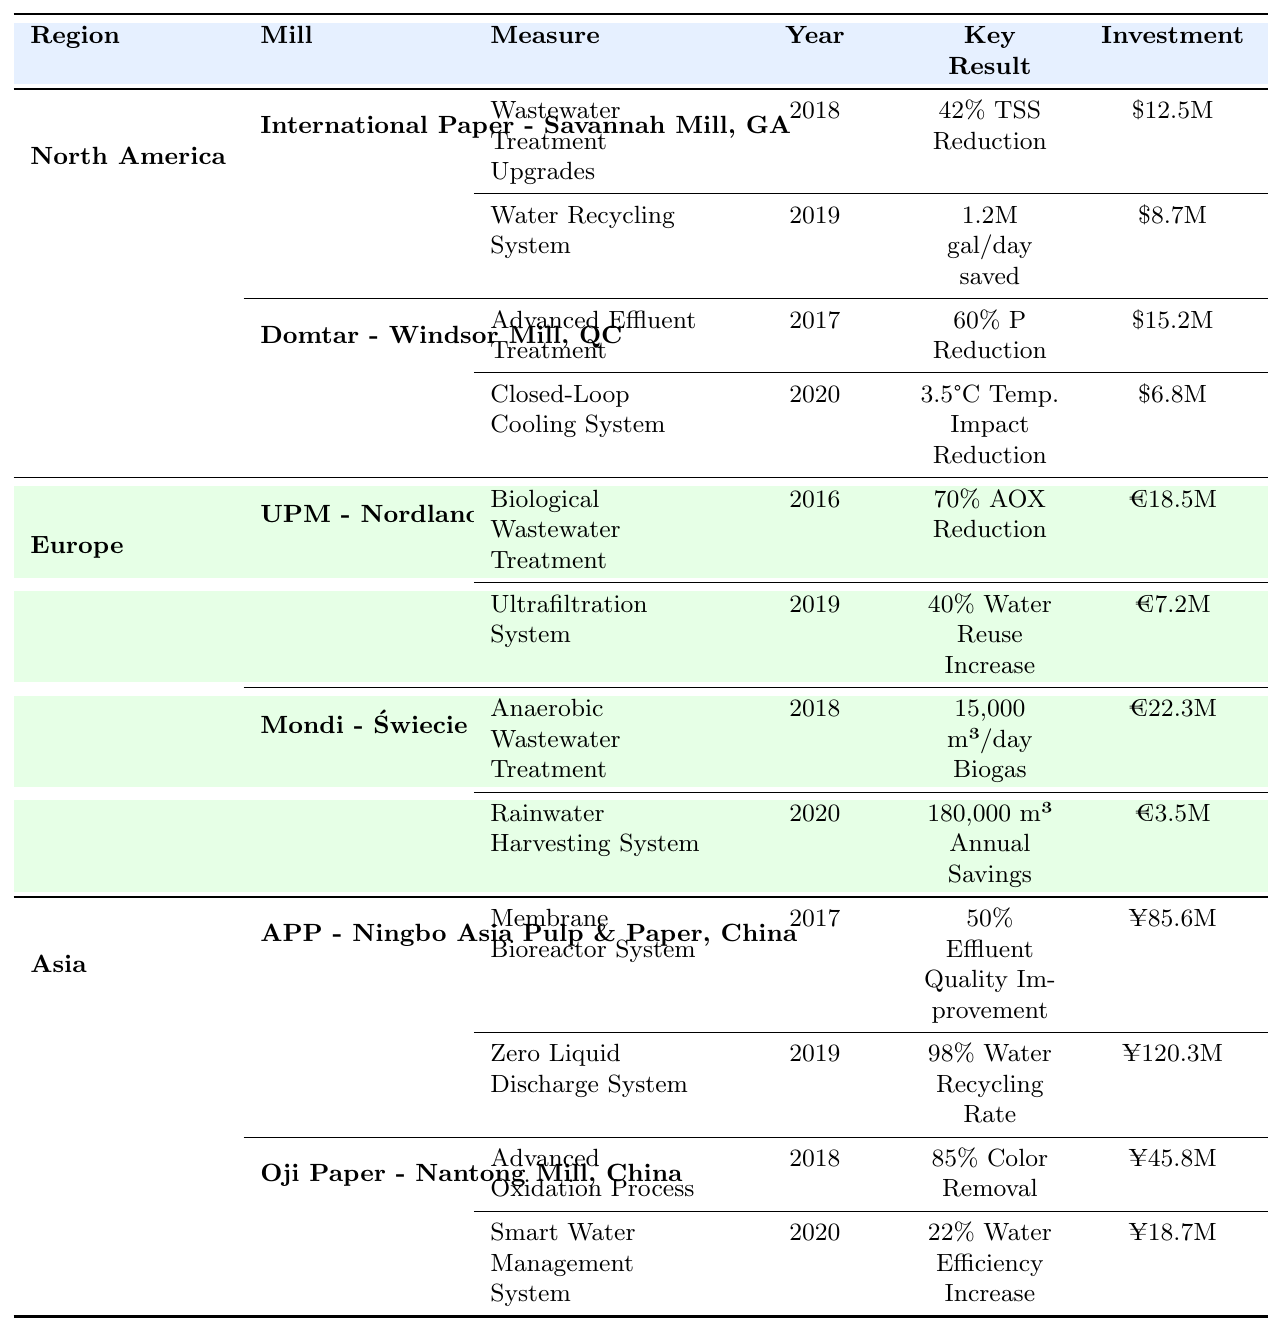What year was the Water Recycling System implemented at International Paper - Savannah Mill? The table shows that the Water Recycling System was implemented in 2019 at International Paper - Savannah Mill.
Answer: 2019 What is the percentage reduction of Biochemical Oxygen Demand (BOD) achieved at International Paper - Savannah Mill? The table indicates that the percentage reduction of BOD achieved at the International Paper - Savannah Mill is 35%.
Answer: 35% Which paper mill reported the highest investment in water quality improvement measures? Looking at the investments listed in the table, Mondi - Świecie Mill, Poland reported the highest investment of 22.3 million EUR for Anaerobic Wastewater Treatment.
Answer: 22.3 million EUR Is there any mill that implemented improvements in both 2018 and 2020? Yes, both Oji Paper - Nantong Mill and Domtar - Windsor Mill implemented measures in both 2018 and 2020.
Answer: Yes What was the total investment made in wastewater treatment measures by International Paper - Savannah Mill? Summing the investments of $12.5 million for Wastewater Treatment Upgrades and $8.7 million for the Water Recycling System gives $12.5M + $8.7M = $21.2 million total investment.
Answer: $21.2 million Which measure at APP - Ningbo Asia Pulp & Paper led to a 98% water recycling rate and in what year was it implemented? The Zero Liquid Discharge System led to a 98% water recycling rate and was implemented in 2019.
Answer: Zero Liquid Discharge System, 2019 How much freshwater demand was reduced by the Rainwater Harvesting System at Mondi - Świecie Mill? The Rainwater Harvesting System at Mondi - Świecie Mill resulted in a 15% reduction in freshwater demand.
Answer: 15% What is the total effluent quality improvement percentage achieved by both APP and Oji Paper mills in Asia? The total effluent quality improvement percentages are 50% for APP and 85% for Oji Paper. Therefore, the total improvement is 50% + 85% = 135%.
Answer: 135% Which region has the mill with the highest reduction of nitrogens and what is that percentage? The table shows that Domtar - Windsor Mill in North America has the highest nitrogen reduction of 45%.
Answer: 45% Between the two mills in Europe, which one has a higher total investment and what is the amount? Comparing the two total investments, UPM - Nordland Papier has €18.5 million and Mondi - Świecie has €22.3 million, making Mondi - Świecie the one with a higher investment of €22.3 million.
Answer: €22.3 million Which paper mill achieved a sludge reduction and what is the percentage? The table indicates that Mondi - Świecie Mill achieved a 35% sludge reduction through its Anaerobic Wastewater Treatment.
Answer: 35% 